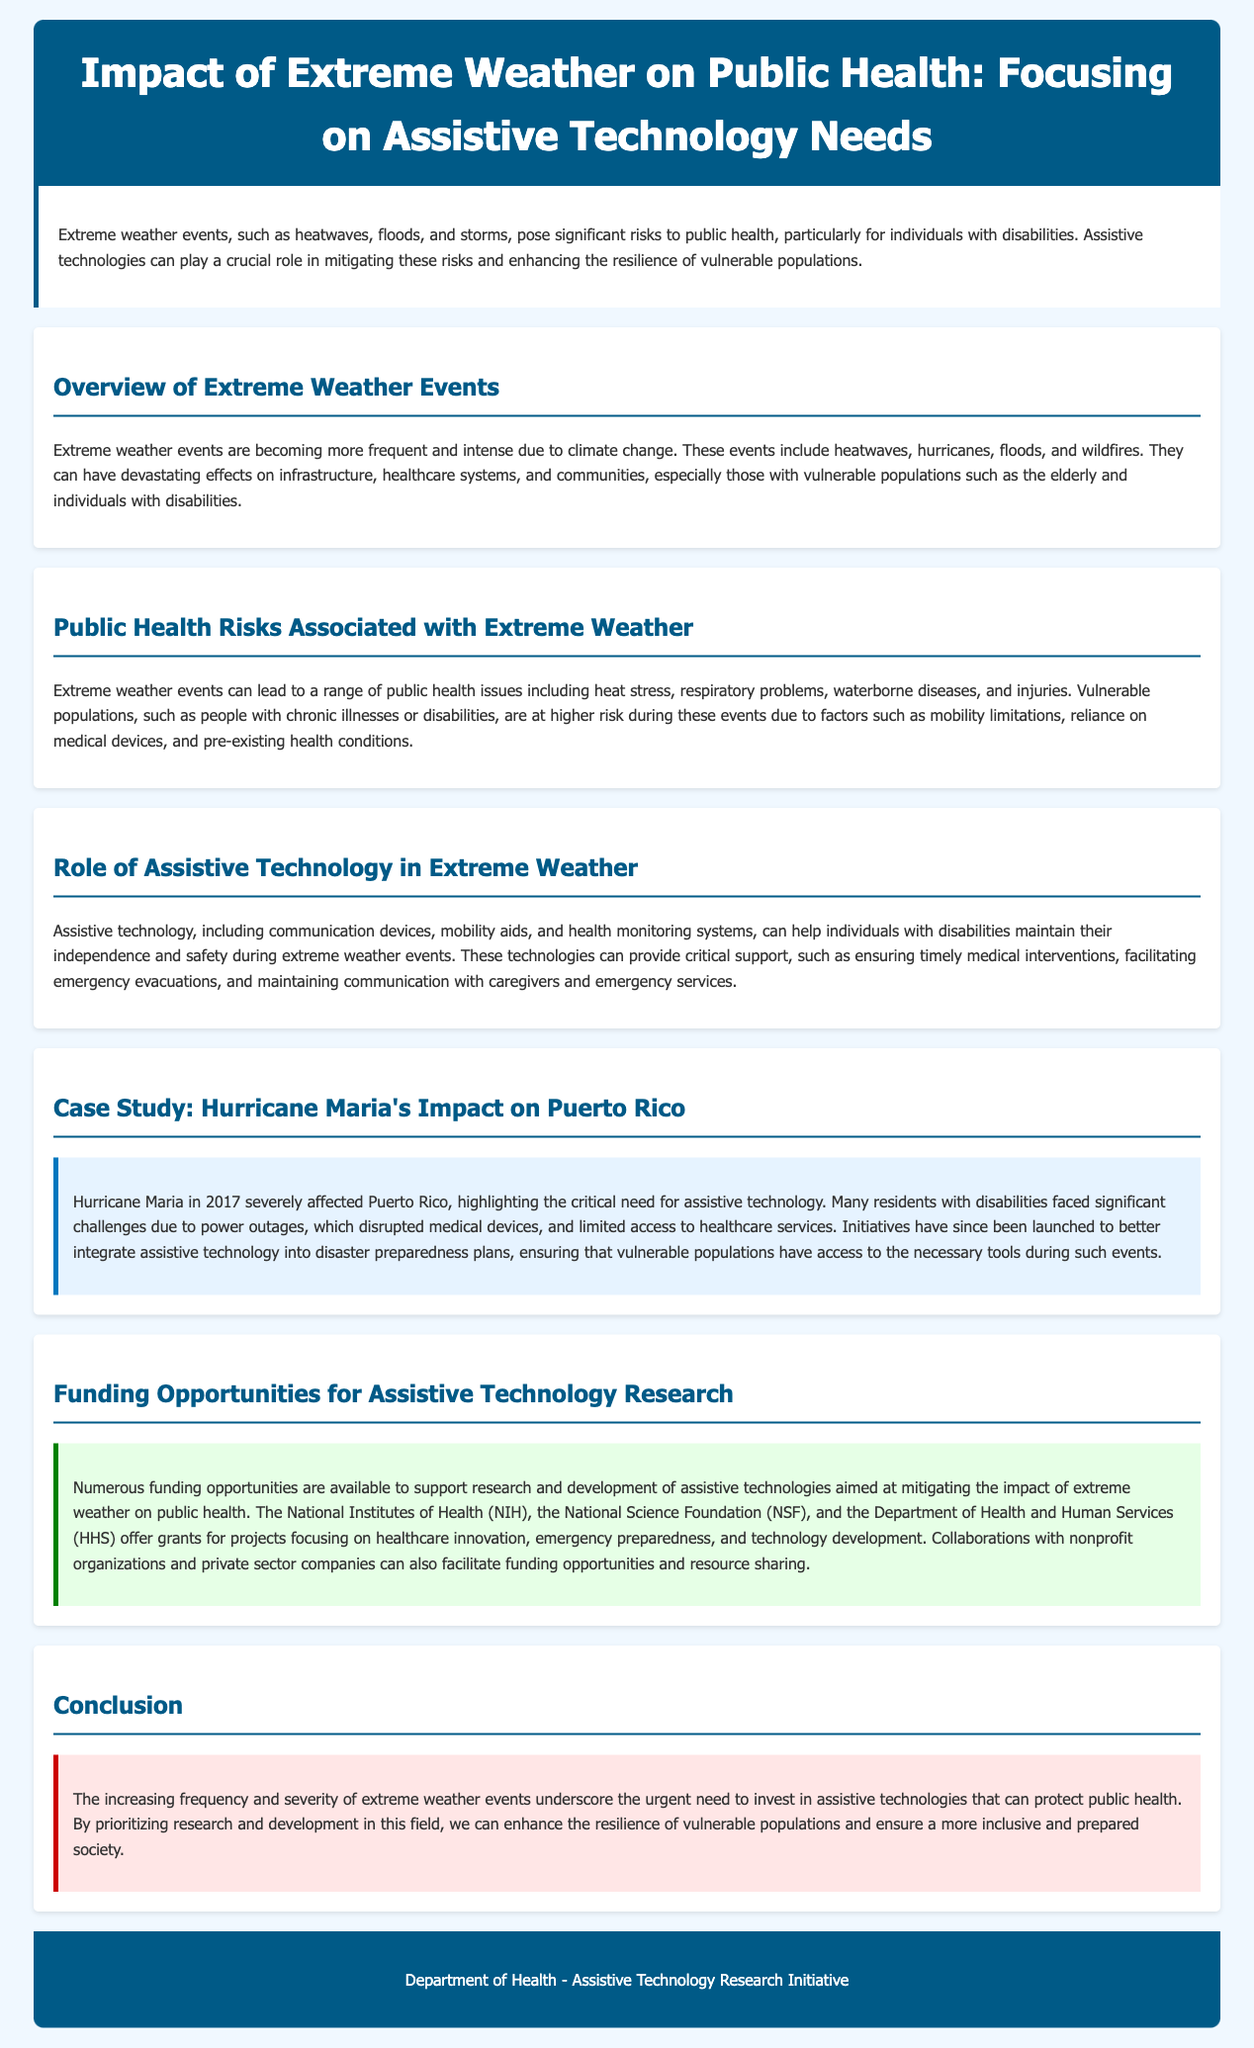What are some examples of extreme weather events? The document mentions heatwaves, hurricanes, floods, and wildfires as examples of extreme weather events.
Answer: heatwaves, hurricanes, floods, wildfires Who are considered vulnerable populations during extreme weather events? Vulnerable populations include the elderly and individuals with disabilities, as stated in the document.
Answer: elderly and individuals with disabilities What public health issues can arise from extreme weather? The document lists heat stress, respiratory problems, waterborne diseases, and injuries as public health issues from extreme weather.
Answer: heat stress, respiratory problems, waterborne diseases, injuries What role does assistive technology play during extreme weather? Assistive technology helps provide critical support like ensuring timely medical interventions and facilitating emergency evacuations.
Answer: critical support Which hurricane is referenced as a case study in the document? The document mentions Hurricane Maria as the specific case study illustrating the impact of extreme weather.
Answer: Hurricane Maria Which organizations offer grants for assistive technology research? The National Institutes of Health (NIH), National Science Foundation (NSF), and Department of Health and Human Services (HHS) are mentioned as grant providers.
Answer: NIH, NSF, HHS What was a significant challenge faced by residents with disabilities during Hurricane Maria? A significant challenge was power outages disrupting medical devices for residents with disabilities.
Answer: power outages What urgent need does the conclusion emphasize? The conclusion emphasizes the urgent need to invest in assistive technologies that can protect public health.
Answer: invest in assistive technologies 